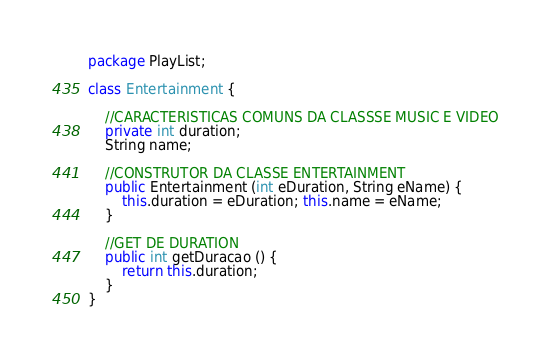<code> <loc_0><loc_0><loc_500><loc_500><_Java_>package PlayList;

class Entertainment {
	
	//CARACTERISTICAS COMUNS DA CLASSSE MUSIC E VIDEO
	private int duration;
	String name;
	
	//CONSTRUTOR DA CLASSE ENTERTAINMENT
	public Entertainment (int eDuration, String eName) {
		this.duration = eDuration; this.name = eName;
	}
	
	//GET DE DURATION
	public int getDuracao () {
		return this.duration;
	}
}</code> 